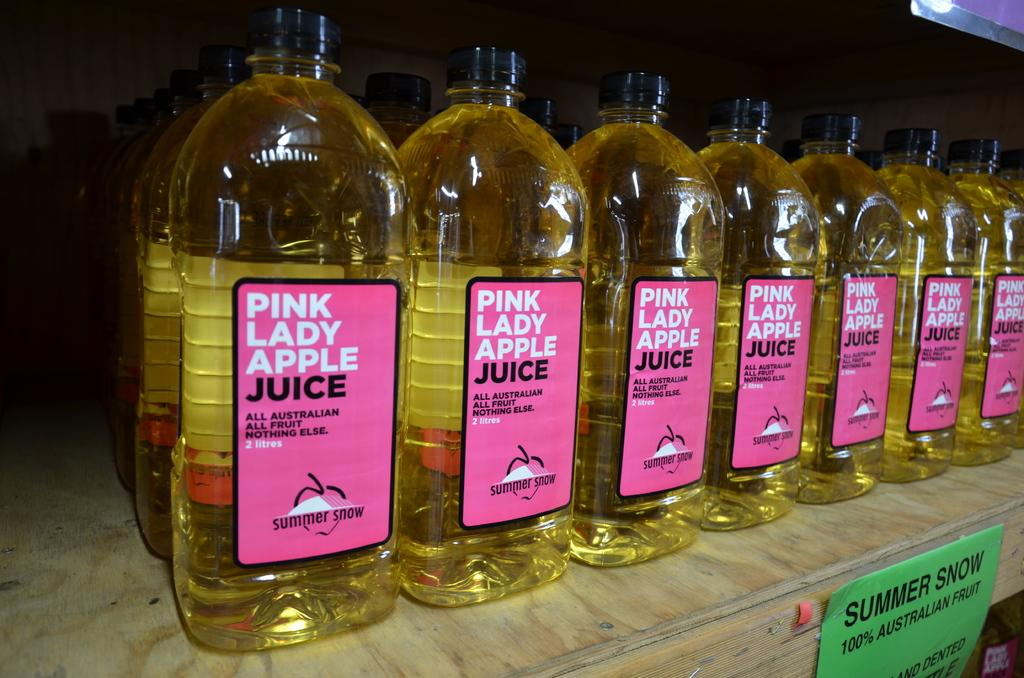<image>
Give a short and clear explanation of the subsequent image. Bottles of Pink Lady Apple Juice sit on a shelf. 